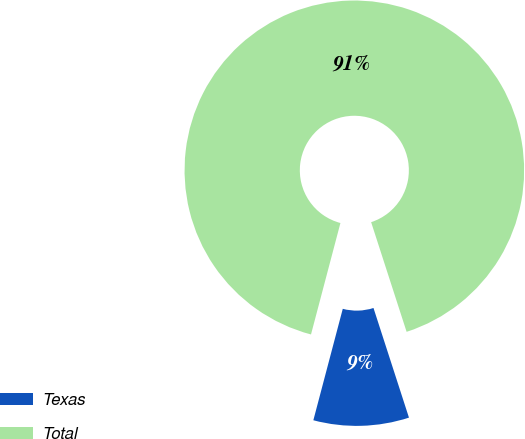Convert chart to OTSL. <chart><loc_0><loc_0><loc_500><loc_500><pie_chart><fcel>Texas<fcel>Total<nl><fcel>9.09%<fcel>90.91%<nl></chart> 